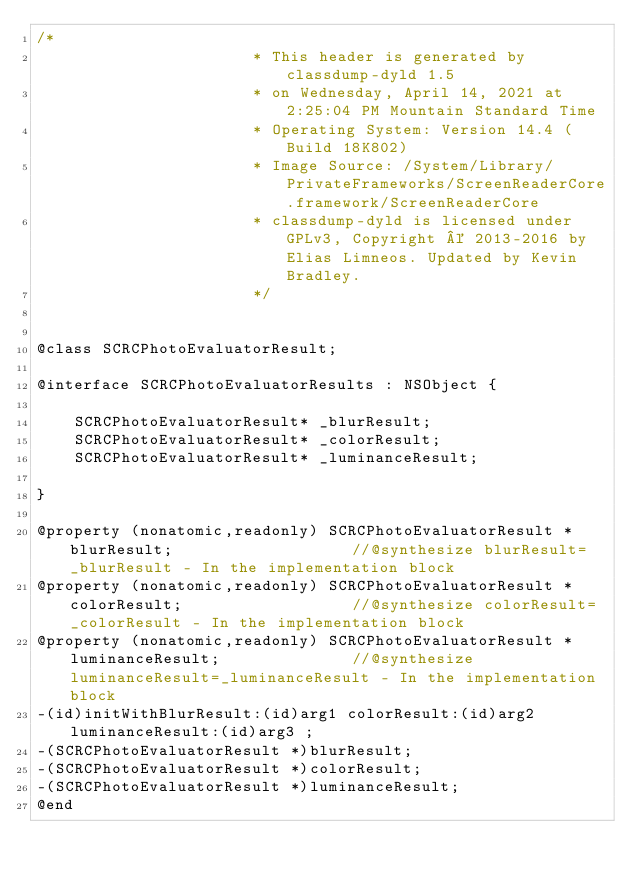Convert code to text. <code><loc_0><loc_0><loc_500><loc_500><_C_>/*
                       * This header is generated by classdump-dyld 1.5
                       * on Wednesday, April 14, 2021 at 2:25:04 PM Mountain Standard Time
                       * Operating System: Version 14.4 (Build 18K802)
                       * Image Source: /System/Library/PrivateFrameworks/ScreenReaderCore.framework/ScreenReaderCore
                       * classdump-dyld is licensed under GPLv3, Copyright © 2013-2016 by Elias Limneos. Updated by Kevin Bradley.
                       */


@class SCRCPhotoEvaluatorResult;

@interface SCRCPhotoEvaluatorResults : NSObject {

	SCRCPhotoEvaluatorResult* _blurResult;
	SCRCPhotoEvaluatorResult* _colorResult;
	SCRCPhotoEvaluatorResult* _luminanceResult;

}

@property (nonatomic,readonly) SCRCPhotoEvaluatorResult * blurResult;                   //@synthesize blurResult=_blurResult - In the implementation block
@property (nonatomic,readonly) SCRCPhotoEvaluatorResult * colorResult;                  //@synthesize colorResult=_colorResult - In the implementation block
@property (nonatomic,readonly) SCRCPhotoEvaluatorResult * luminanceResult;              //@synthesize luminanceResult=_luminanceResult - In the implementation block
-(id)initWithBlurResult:(id)arg1 colorResult:(id)arg2 luminanceResult:(id)arg3 ;
-(SCRCPhotoEvaluatorResult *)blurResult;
-(SCRCPhotoEvaluatorResult *)colorResult;
-(SCRCPhotoEvaluatorResult *)luminanceResult;
@end

</code> 